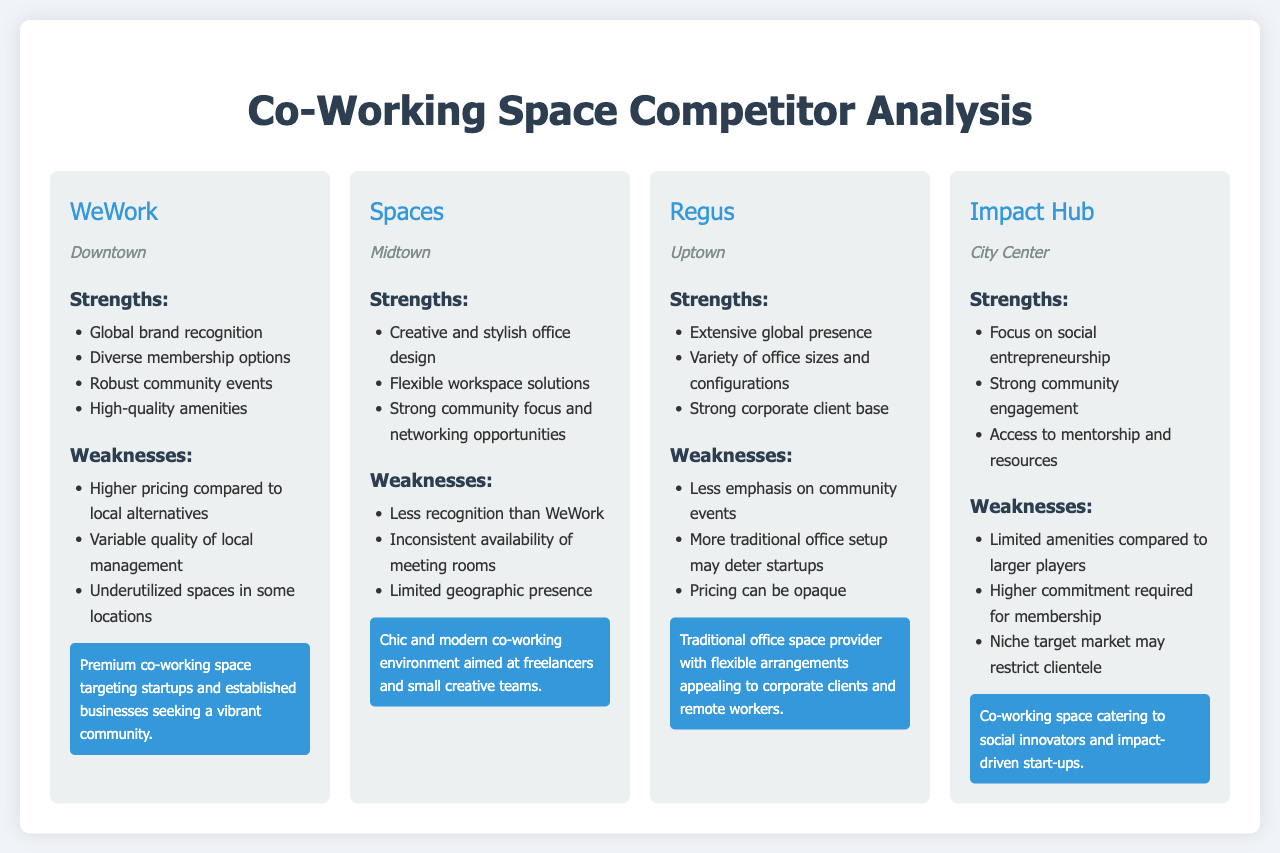What is the location of WeWork? WeWork is located in Downtown, as listed in the document.
Answer: Downtown What are the strengths of Spaces? The document lists several strengths for Spaces, including creative and stylish office design, flexible workspace solutions, and a strong community focus.
Answer: Creative and stylish office design What is the primary market positioning of Regus? Regus's market positioning describes it as a traditional office space provider appealing to corporate clients and remote workers.
Answer: Traditional office space provider How many weaknesses are listed for Impact Hub? The document lists three weaknesses for Impact Hub.
Answer: Three Which competitor has a strong corporate client base? Among the competitors, Regus is noted for having a strong corporate client base.
Answer: Regus What is a key area where WeWork is criticized? WeWork is criticized for having higher pricing compared to local alternatives.
Answer: Higher pricing What type of clientele does Impact Hub primarily cater to? Impact Hub primarily caters to social innovators and impact-driven start-ups according to the market positioning.
Answer: Social innovators Which competitor is described as having robust community events? The document describes WeWork as having robust community events in its strengths.
Answer: WeWork What is a common weakness for several competitors? A common weakness noted for several competitors is inconsistent availability or variable quality in offering services.
Answer: Inconsistent availability 